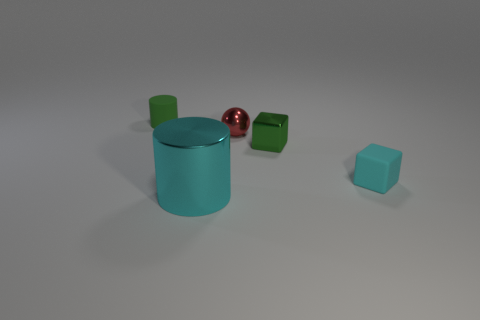Are there any other things that are the same size as the metal cylinder?
Ensure brevity in your answer.  No. What number of tiny rubber cylinders are on the left side of the matte object that is in front of the metal sphere?
Your response must be concise. 1. There is a matte object in front of the small green rubber thing; is there a shiny cylinder that is behind it?
Your response must be concise. No. Are there any shiny blocks right of the red thing?
Provide a short and direct response. Yes. Do the small rubber object in front of the small green rubber object and the small green metal thing have the same shape?
Give a very brief answer. Yes. How many large cyan objects have the same shape as the tiny green matte thing?
Offer a very short reply. 1. Are there any cyan cubes made of the same material as the small green cylinder?
Provide a succinct answer. Yes. What material is the cylinder that is behind the cyan object to the left of the red thing made of?
Give a very brief answer. Rubber. There is a cyan object that is on the right side of the red ball; what is its size?
Ensure brevity in your answer.  Small. There is a rubber cylinder; is its color the same as the small block left of the cyan matte block?
Make the answer very short. Yes. 